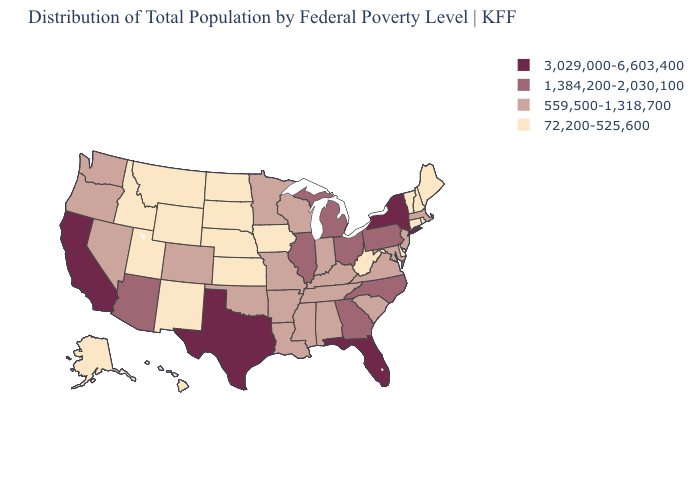Among the states that border New Hampshire , does Massachusetts have the highest value?
Answer briefly. Yes. Does the first symbol in the legend represent the smallest category?
Write a very short answer. No. Is the legend a continuous bar?
Quick response, please. No. Among the states that border Arkansas , which have the lowest value?
Be succinct. Louisiana, Mississippi, Missouri, Oklahoma, Tennessee. How many symbols are there in the legend?
Quick response, please. 4. Does West Virginia have the same value as Florida?
Keep it brief. No. Does Ohio have the same value as Alabama?
Quick response, please. No. Does California have the highest value in the USA?
Concise answer only. Yes. What is the lowest value in the USA?
Concise answer only. 72,200-525,600. Is the legend a continuous bar?
Short answer required. No. Does California have the highest value in the West?
Concise answer only. Yes. Does the first symbol in the legend represent the smallest category?
Short answer required. No. What is the lowest value in the USA?
Short answer required. 72,200-525,600. What is the value of Alaska?
Answer briefly. 72,200-525,600. Does Missouri have the lowest value in the MidWest?
Give a very brief answer. No. 